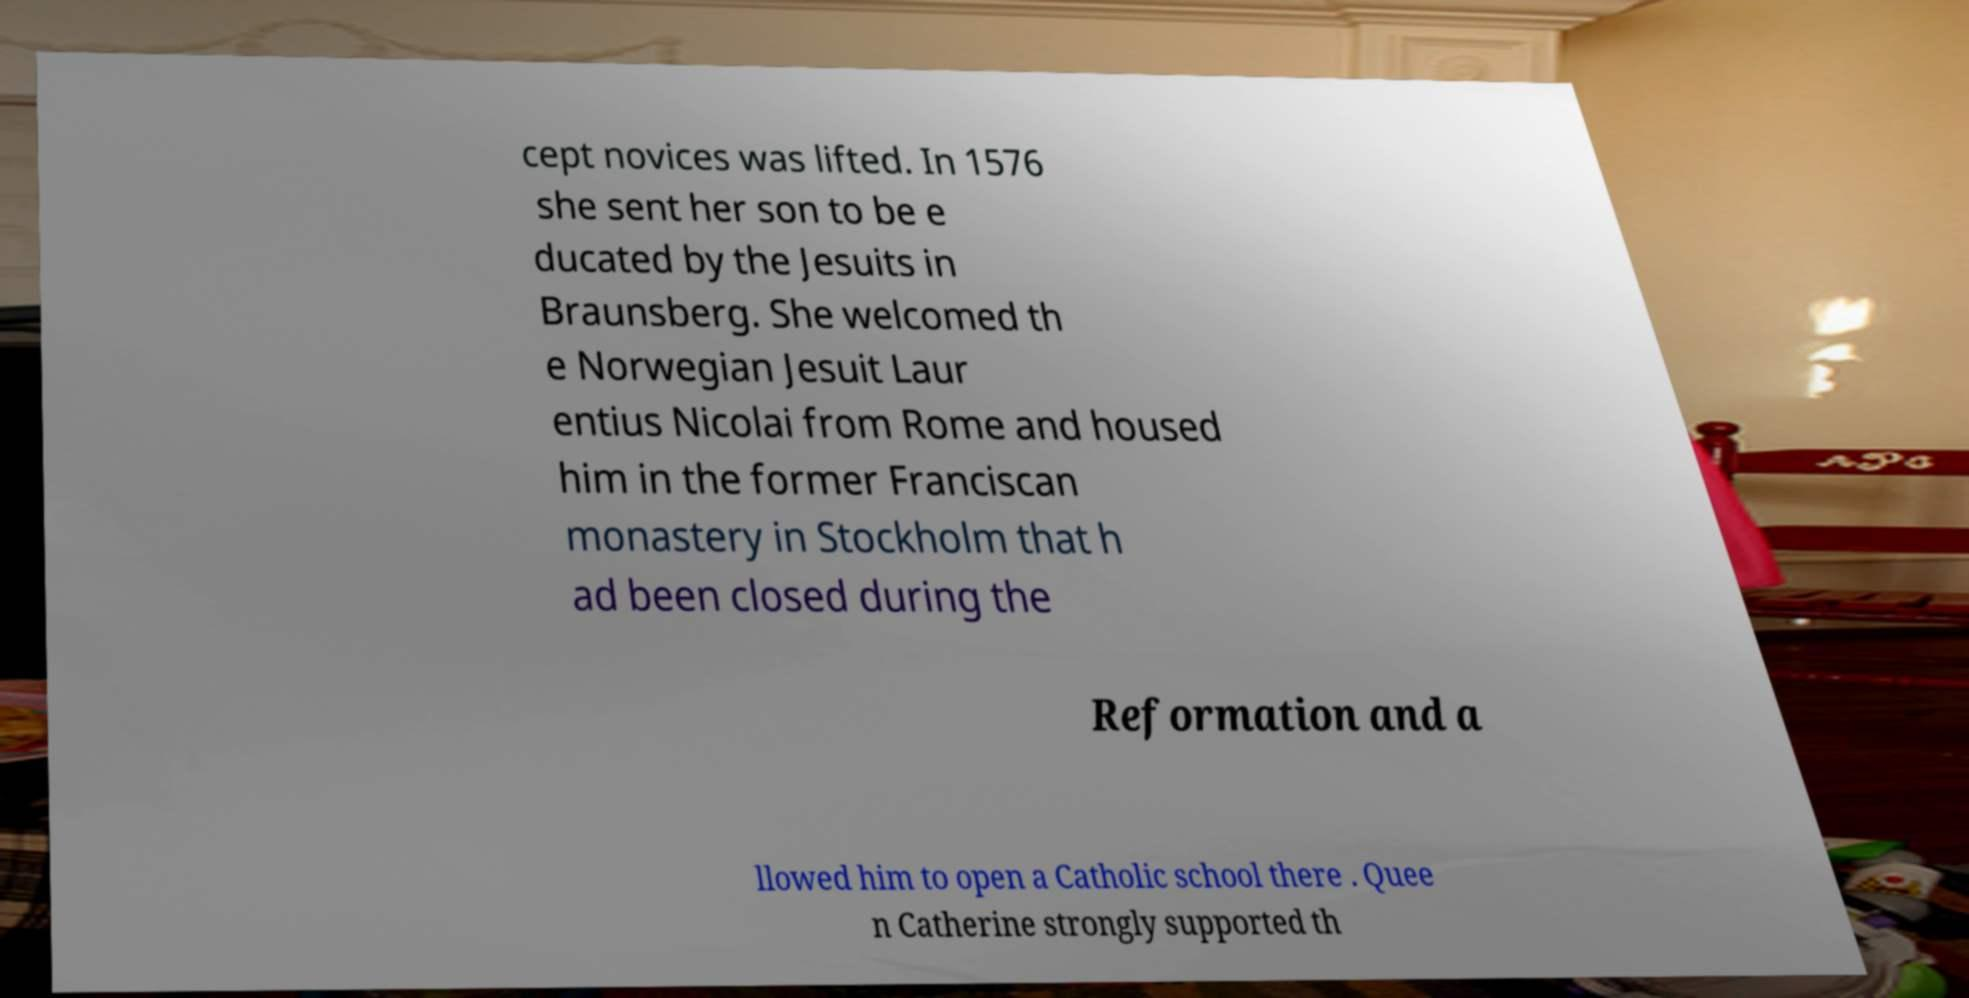Could you extract and type out the text from this image? cept novices was lifted. In 1576 she sent her son to be e ducated by the Jesuits in Braunsberg. She welcomed th e Norwegian Jesuit Laur entius Nicolai from Rome and housed him in the former Franciscan monastery in Stockholm that h ad been closed during the Reformation and a llowed him to open a Catholic school there . Quee n Catherine strongly supported th 